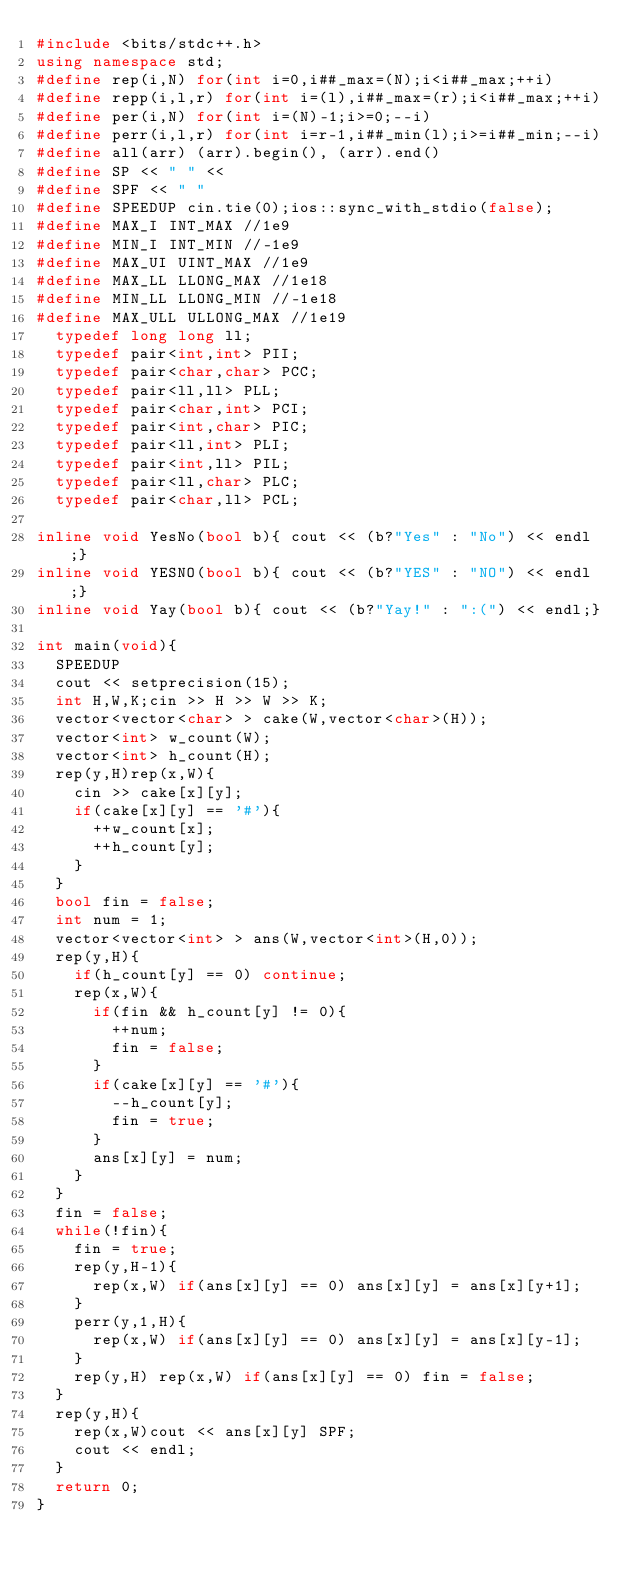<code> <loc_0><loc_0><loc_500><loc_500><_C++_>#include <bits/stdc++.h>
using namespace std;
#define rep(i,N) for(int i=0,i##_max=(N);i<i##_max;++i)
#define repp(i,l,r) for(int i=(l),i##_max=(r);i<i##_max;++i)
#define per(i,N) for(int i=(N)-1;i>=0;--i)
#define perr(i,l,r) for(int i=r-1,i##_min(l);i>=i##_min;--i)
#define all(arr) (arr).begin(), (arr).end()
#define SP << " " <<
#define SPF << " "
#define SPEEDUP cin.tie(0);ios::sync_with_stdio(false);
#define MAX_I INT_MAX //1e9
#define MIN_I INT_MIN //-1e9
#define MAX_UI UINT_MAX //1e9
#define MAX_LL LLONG_MAX //1e18
#define MIN_LL LLONG_MIN //-1e18
#define MAX_ULL ULLONG_MAX //1e19
  typedef long long ll;
  typedef pair<int,int> PII;
  typedef pair<char,char> PCC;
  typedef pair<ll,ll> PLL;
  typedef pair<char,int> PCI;
  typedef pair<int,char> PIC;
  typedef pair<ll,int> PLI;
  typedef pair<int,ll> PIL; 
  typedef pair<ll,char> PLC; 
  typedef pair<char,ll> PCL; 

inline void YesNo(bool b){ cout << (b?"Yes" : "No") << endl;}
inline void YESNO(bool b){ cout << (b?"YES" : "NO") << endl;}
inline void Yay(bool b){ cout << (b?"Yay!" : ":(") << endl;}

int main(void){
  SPEEDUP
  cout << setprecision(15);
  int H,W,K;cin >> H >> W >> K;
  vector<vector<char> > cake(W,vector<char>(H));
  vector<int> w_count(W);
  vector<int> h_count(H);
  rep(y,H)rep(x,W){
    cin >> cake[x][y];
    if(cake[x][y] == '#'){
      ++w_count[x];
      ++h_count[y];
    }
  }
  bool fin = false;
  int num = 1;
  vector<vector<int> > ans(W,vector<int>(H,0));
  rep(y,H){
    if(h_count[y] == 0) continue;
    rep(x,W){
      if(fin && h_count[y] != 0){
        ++num;
        fin = false;
      }
      if(cake[x][y] == '#'){
        --h_count[y];
        fin = true;
      }
      ans[x][y] = num;
    }
  }
  fin = false;
  while(!fin){
    fin = true;
    rep(y,H-1){
      rep(x,W) if(ans[x][y] == 0) ans[x][y] = ans[x][y+1];
    }
    perr(y,1,H){
      rep(x,W) if(ans[x][y] == 0) ans[x][y] = ans[x][y-1];
    }
    rep(y,H) rep(x,W) if(ans[x][y] == 0) fin = false;
  }
  rep(y,H){
    rep(x,W)cout << ans[x][y] SPF;
    cout << endl;
  }
  return 0;
}
</code> 